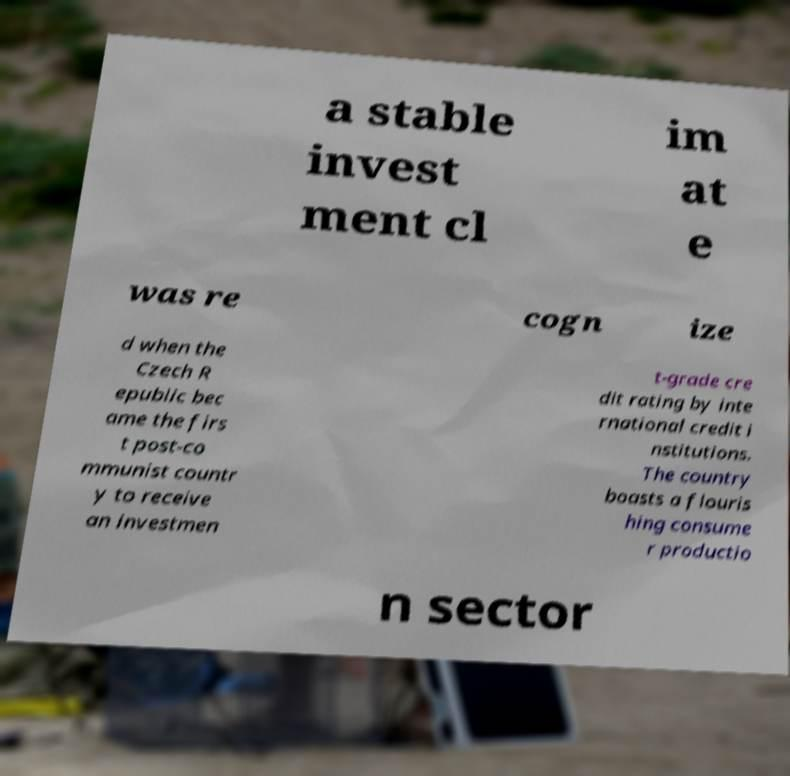Could you extract and type out the text from this image? a stable invest ment cl im at e was re cogn ize d when the Czech R epublic bec ame the firs t post-co mmunist countr y to receive an investmen t-grade cre dit rating by inte rnational credit i nstitutions. The country boasts a flouris hing consume r productio n sector 